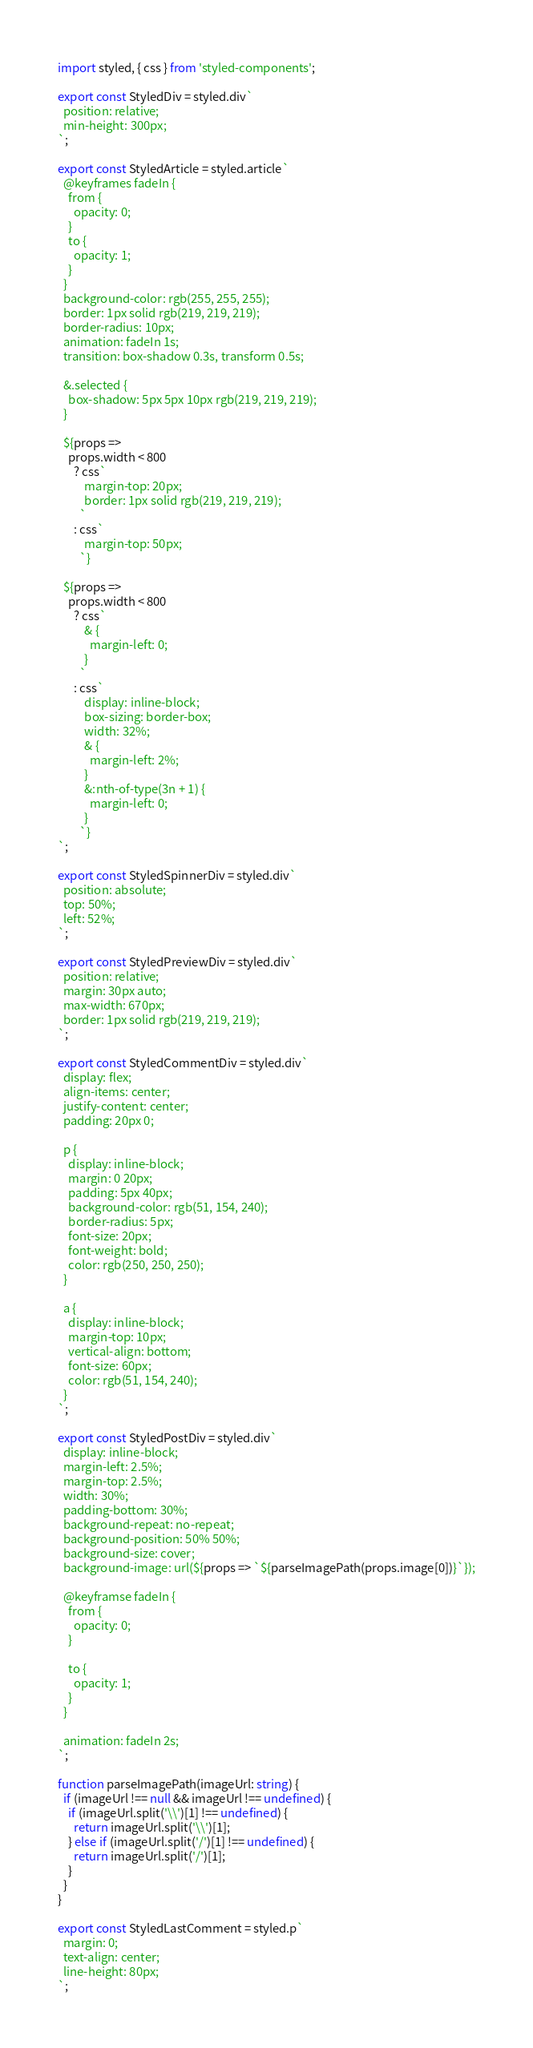Convert code to text. <code><loc_0><loc_0><loc_500><loc_500><_TypeScript_>import styled, { css } from 'styled-components';

export const StyledDiv = styled.div`
  position: relative;
  min-height: 300px;
`;

export const StyledArticle = styled.article`
  @keyframes fadeIn {
    from {
      opacity: 0;
    }
    to {
      opacity: 1;
    }
  }
  background-color: rgb(255, 255, 255);
  border: 1px solid rgb(219, 219, 219);
  border-radius: 10px;
  animation: fadeIn 1s;
  transition: box-shadow 0.3s, transform 0.5s;

  &.selected {
    box-shadow: 5px 5px 10px rgb(219, 219, 219);
  }

  ${props =>
    props.width < 800
      ? css`
          margin-top: 20px;
          border: 1px solid rgb(219, 219, 219);
        `
      : css`
          margin-top: 50px;
        `}

  ${props =>
    props.width < 800
      ? css`
          & {
            margin-left: 0;
          }
        `
      : css`
          display: inline-block;
          box-sizing: border-box;
          width: 32%;
          & {
            margin-left: 2%;
          }
          &:nth-of-type(3n + 1) {
            margin-left: 0;
          }
        `}
`;

export const StyledSpinnerDiv = styled.div`
  position: absolute;
  top: 50%;
  left: 52%;
`;

export const StyledPreviewDiv = styled.div`
  position: relative;
  margin: 30px auto;
  max-width: 670px;
  border: 1px solid rgb(219, 219, 219);
`;

export const StyledCommentDiv = styled.div`
  display: flex;
  align-items: center;
  justify-content: center;
  padding: 20px 0;

  p {
    display: inline-block;
    margin: 0 20px;
    padding: 5px 40px;
    background-color: rgb(51, 154, 240);
    border-radius: 5px;
    font-size: 20px;
    font-weight: bold;
    color: rgb(250, 250, 250);
  }

  a {
    display: inline-block;
    margin-top: 10px;
    vertical-align: bottom;
    font-size: 60px;
    color: rgb(51, 154, 240);
  }
`;

export const StyledPostDiv = styled.div`
  display: inline-block;
  margin-left: 2.5%;
  margin-top: 2.5%;
  width: 30%;
  padding-bottom: 30%;
  background-repeat: no-repeat;
  background-position: 50% 50%;
  background-size: cover;
  background-image: url(${props => `${parseImagePath(props.image[0])}`});

  @keyframse fadeIn {
    from {
      opacity: 0;
    }

    to {
      opacity: 1;
    }
  }

  animation: fadeIn 2s;
`;

function parseImagePath(imageUrl: string) {
  if (imageUrl !== null && imageUrl !== undefined) {
    if (imageUrl.split('\\')[1] !== undefined) {
      return imageUrl.split('\\')[1];
    } else if (imageUrl.split('/')[1] !== undefined) {
      return imageUrl.split('/')[1];
    }
  }
}

export const StyledLastComment = styled.p`
  margin: 0;
  text-align: center;
  line-height: 80px;
`;</code> 